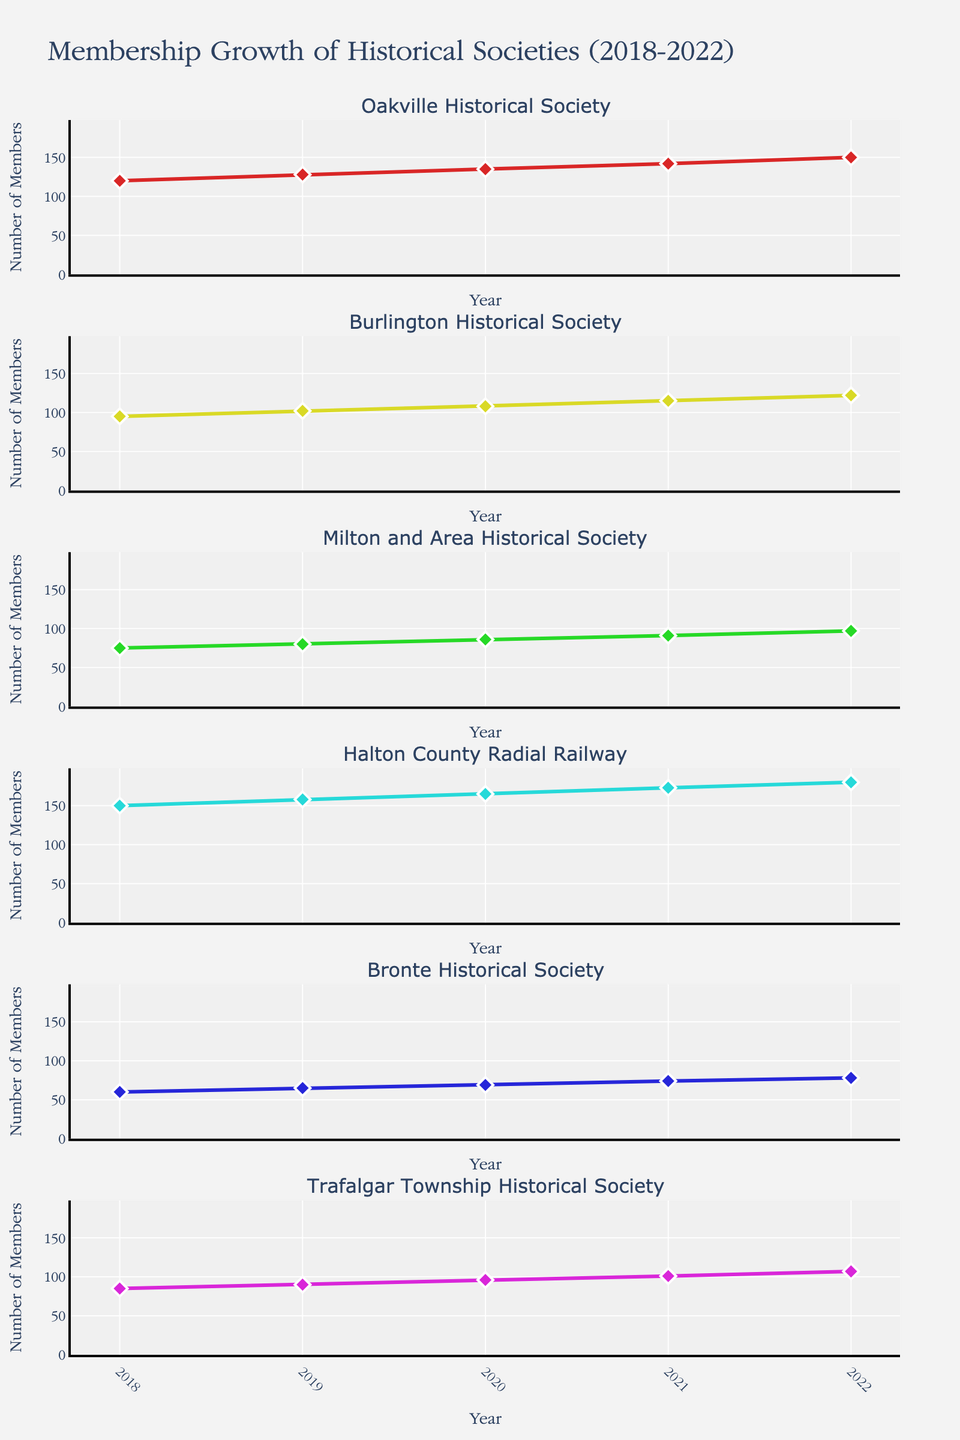What's the title of the figure? The title is right at the top center of the figure.
Answer: Membership Growth of Historical Societies (2018-2022) Which historical society had the highest number of members in 2022? We look at the last data point (2022) in the subplot for each historical society and identify the highest one.
Answer: Halton County Radial Railway How much did the membership of the Milton and Area Historical Society increase from 2018 to 2022? Find the difference between the membership numbers in 2022 (97) and 2018 (75). Calculation: 97 - 75.
Answer: 22 Which historical society had the smallest membership growth from 2018 to 2022? Calculate the increase in membership for each society by subtracting the 2018 figure from the 2022 figure. The smallest difference will be the answer.
Answer: Bronte Historical Society Between 2019 and 2020, which historical society saw the largest percentage increase in membership? Calculate the percentage increase for each society by using the formula: ((2020 number - 2019 number) / 2019 number) * 100. Compare these percentages to find the largest one.
Answer: Milton and Area Historical Society Which two historical societies had an equal number of members at any point in time shown in the plot? Observe each subplot to compare the membership numbers year by year and identify any overlaps.
Answer: Bronte Historical Society and Trafalgar Township Historical Society in 2019 What’s the average membership number for the Burlington Historical Society from 2018 to 2022? Calculate the average by summing the membership numbers from 2018 to 2022 (95 + 102 + 108 + 115 + 122) and divide by 5. Calculation: (95 + 102 + 108 + 115 + 122) / 5.
Answer: 108.4 Which historical society's membership consistently increased every year? Look at each society's membership plotted over the years and check if there are no decreases year to year.
Answer: All societies Compare the membership growth of the Oakville Historical Society and the Halton County Radial Railway. Which society had higher absolute growth over the period? Calculate the absolute growth for each: subtract the 2018 value from the 2022 value for both societies. Compare the differences. Oakville: 150 - 120 = 30, Halton: 180 - 150 = 30.
Answer: Both had equal absolute growth From the subplots, which society had the most diverse membership growth pattern (i.e., least consistent)? Analyze the lines in each subplot for their consistency over the years. The society with the most fluctuation would be the least consistent.
Answer: Trafalgar Township Historical Society 